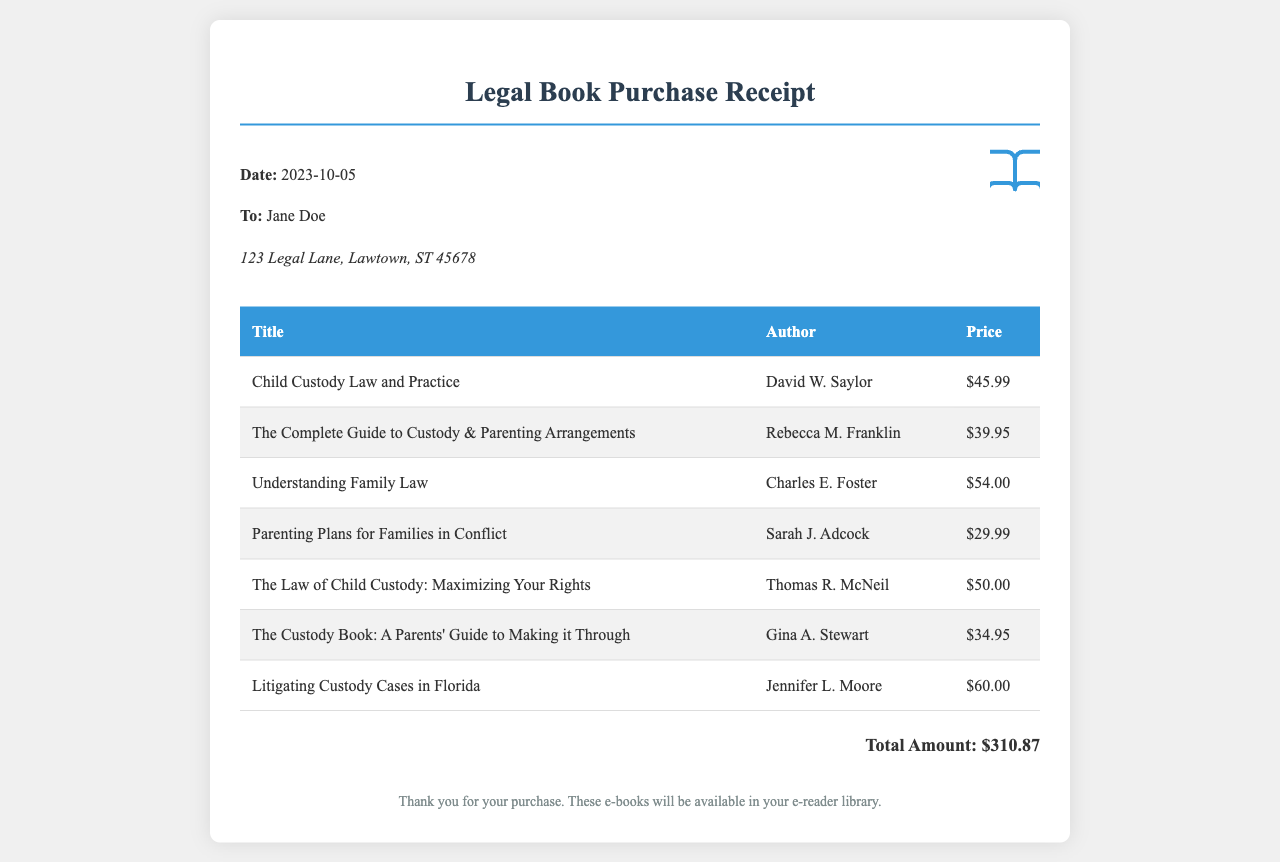What is the total amount spent? The total amount is explicitly stated as the sum of all book prices listed in the document.
Answer: $310.87 Who is the author of "Understanding Family Law"? This information can be found in the table of book titles and authors.
Answer: Charles E. Foster When was the purchase made? The date is included in the header section of the receipt.
Answer: 2023-10-05 Which book costs the most? By comparing the prices listed for each book, we can identify the highest price.
Answer: Litigating Custody Cases in Florida How many books were purchased? This can be determined by counting the number of entries in the book list found in the table.
Answer: 7 What is the price of "Parenting Plans for Families in Conflict"? The price for this specific book is listed in the corresponding table row.
Answer: $29.99 What kind of document is this? This document contains a receipt format, indicating a purchase of items.
Answer: Receipt What is the recipient's address? The address for the recipient is provided in the header section of the receipt.
Answer: 123 Legal Lane, Lawtown, ST 45678 Who is the author of "The Custody Book: A Parents' Guide to Making it Through"? The author is found next to the book title in the document's table.
Answer: Gina A. Stewart 